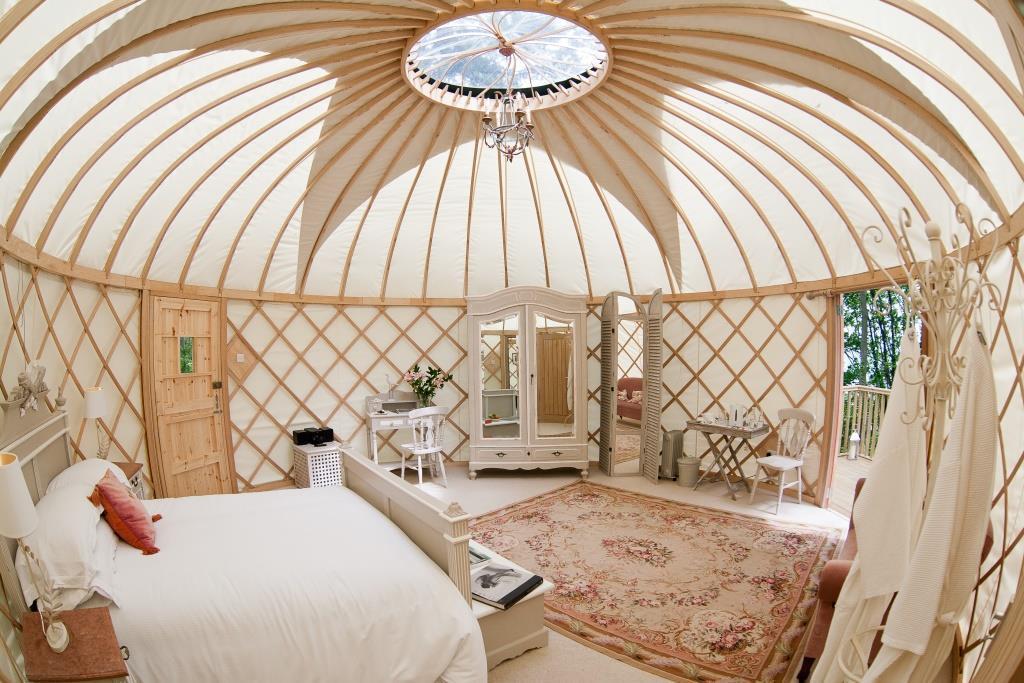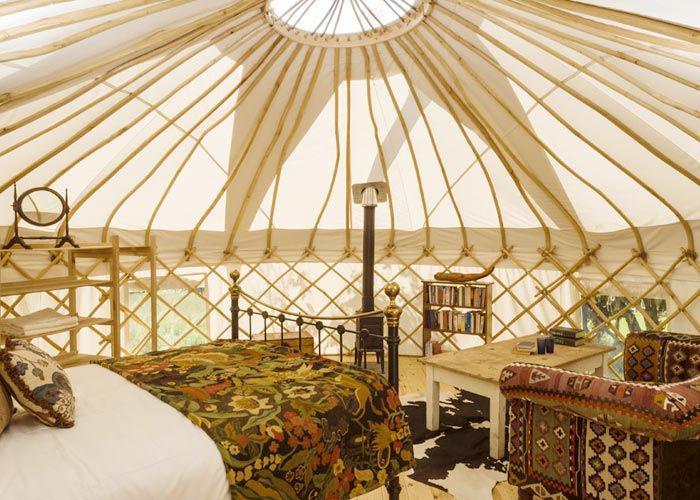The first image is the image on the left, the second image is the image on the right. For the images shown, is this caption "One image shows a room with a non-animal patterned run near the center." true? Answer yes or no. Yes. The first image is the image on the left, the second image is the image on the right. Assess this claim about the two images: "There is one striped pillow in the image on the right.". Correct or not? Answer yes or no. No. 